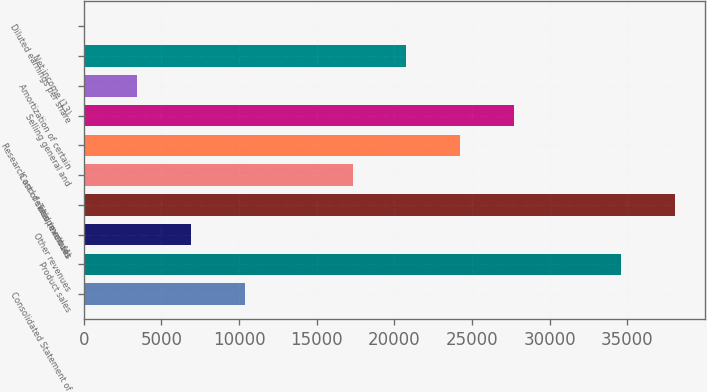Convert chart to OTSL. <chart><loc_0><loc_0><loc_500><loc_500><bar_chart><fcel>Consolidated Statement of<fcel>Product sales<fcel>Other revenues<fcel>Total revenues<fcel>Cost of sales (excludes<fcel>Research and development (4)<fcel>Selling general and<fcel>Amortization of certain<fcel>Net income (13)<fcel>Diluted earnings per share<nl><fcel>10387.3<fcel>34618<fcel>6925.8<fcel>38079.6<fcel>17310.4<fcel>24233.5<fcel>27695<fcel>3464.27<fcel>20771.9<fcel>2.74<nl></chart> 